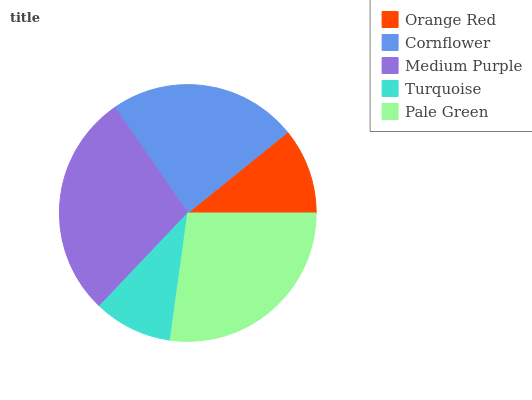Is Turquoise the minimum?
Answer yes or no. Yes. Is Medium Purple the maximum?
Answer yes or no. Yes. Is Cornflower the minimum?
Answer yes or no. No. Is Cornflower the maximum?
Answer yes or no. No. Is Cornflower greater than Orange Red?
Answer yes or no. Yes. Is Orange Red less than Cornflower?
Answer yes or no. Yes. Is Orange Red greater than Cornflower?
Answer yes or no. No. Is Cornflower less than Orange Red?
Answer yes or no. No. Is Cornflower the high median?
Answer yes or no. Yes. Is Cornflower the low median?
Answer yes or no. Yes. Is Pale Green the high median?
Answer yes or no. No. Is Orange Red the low median?
Answer yes or no. No. 